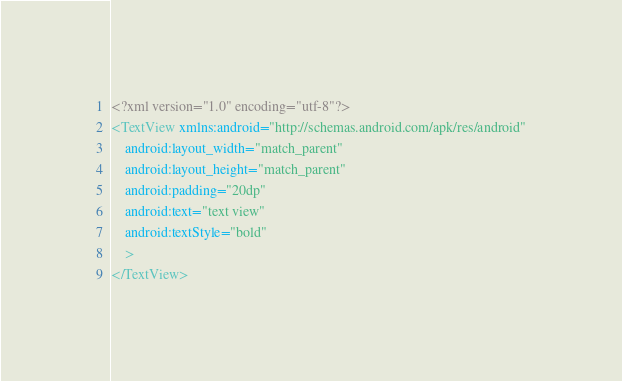<code> <loc_0><loc_0><loc_500><loc_500><_XML_><?xml version="1.0" encoding="utf-8"?>
<TextView xmlns:android="http://schemas.android.com/apk/res/android"
    android:layout_width="match_parent"
    android:layout_height="match_parent"
    android:padding="20dp"
    android:text="text view"
    android:textStyle="bold"
    >
</TextView></code> 